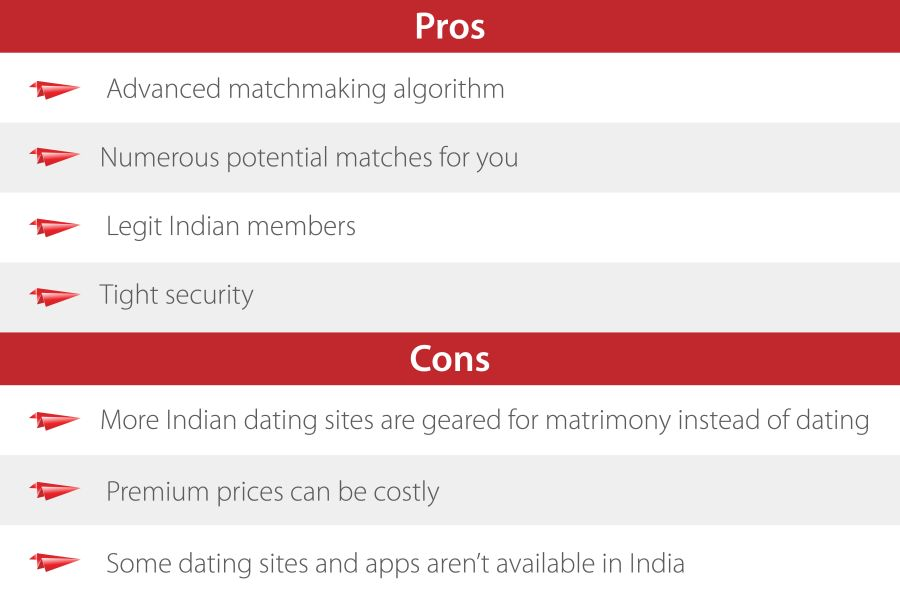Considering the context of the image, what might be the intended audience or user base for the service being described by the list of Pros and Cons? The intended audience for the service shown in the image appears to be singles in India seeking a reliable and effective online dating platform. The 'Pros' such as 'advanced matchmaking algorithm', 'legit Indian members', and 'tight security' suggest the service prioritizes genuine connections and safety, appealing to individuals looking for substantive rather than casual relationships. Conversely, the 'Cons' highlight concerns like the dominance of matrimony over dating and high costs, which could deter those with casual dating interests or budget constraints. 